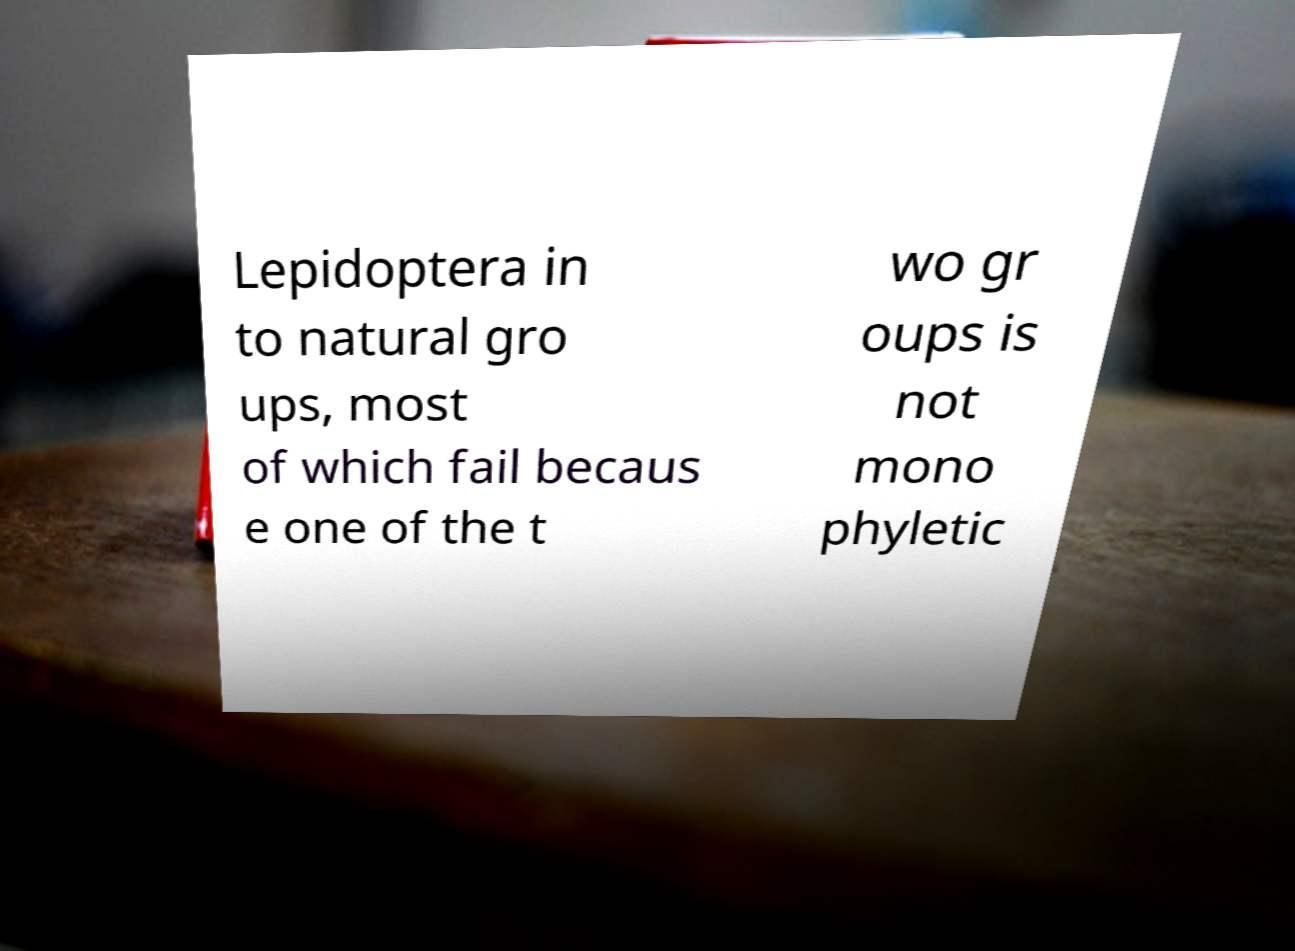For documentation purposes, I need the text within this image transcribed. Could you provide that? Lepidoptera in to natural gro ups, most of which fail becaus e one of the t wo gr oups is not mono phyletic 